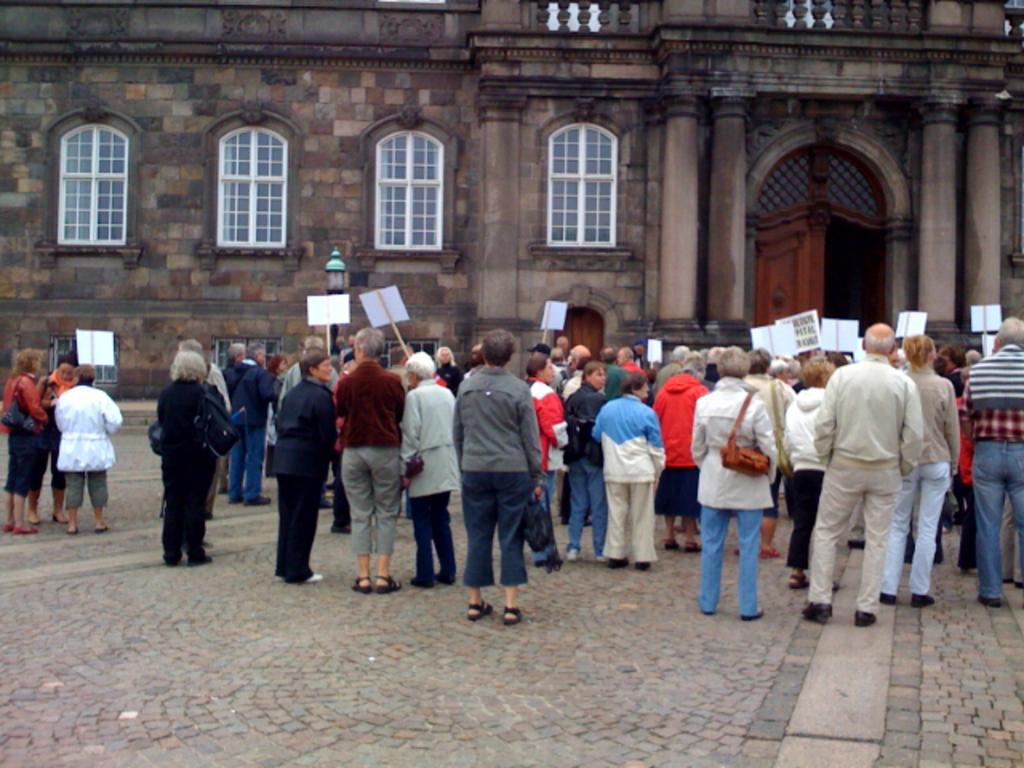How many people are in the image? There are many people in the image. What is the location of the people in the image? The people are standing in front of a building. What are the people holding in their hands? The people are holding boards in their hands. What might be the reason for the people's actions in the image? The people's actions suggest they are protesting against something. Can you see any bees buzzing around the people in the image? There are no bees visible in the image. What type of wound can be seen on the building in the image? There is no wound visible on the building in the image. 